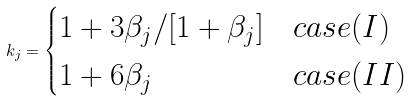Convert formula to latex. <formula><loc_0><loc_0><loc_500><loc_500>k _ { j } = \begin{cases} 1 + 3 \beta _ { j } / [ 1 + \beta _ { j } ] & c a s e ( I ) \\ 1 + 6 \beta _ { j } & c a s e ( I I ) \end{cases}</formula> 